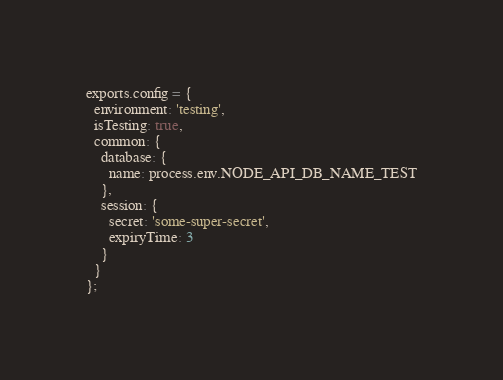<code> <loc_0><loc_0><loc_500><loc_500><_JavaScript_>exports.config = {
  environment: 'testing',
  isTesting: true,
  common: {
    database: {
      name: process.env.NODE_API_DB_NAME_TEST
    },
    session: {
      secret: 'some-super-secret',
      expiryTime: 3
    }
  }
};
</code> 